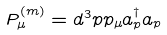Convert formula to latex. <formula><loc_0><loc_0><loc_500><loc_500>P _ { \mu } ^ { ( m ) } = d ^ { 3 } p p _ { \mu } a _ { p } ^ { \dagger } a _ { p }</formula> 